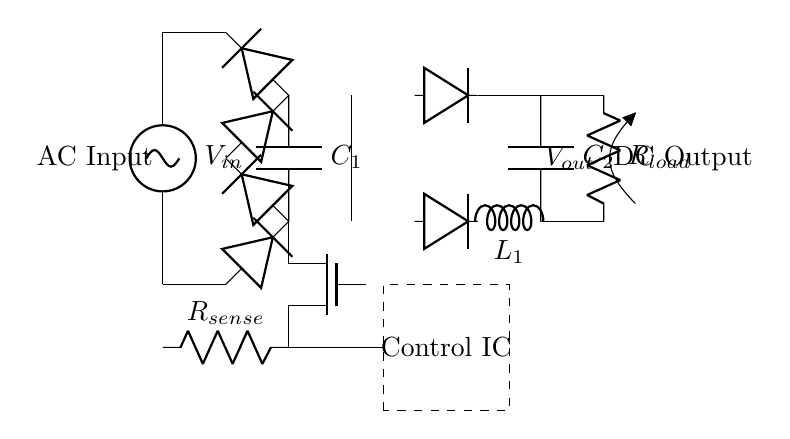What is the input voltage of the circuit? The input voltage is indicated as V_in, which is the source voltage supplying the circuit.
Answer: V_in What component smooths the rectified output? The smoothing capacitor labeled C_1 is connected between the two outputs of the bridge rectifier to filter the DC output and reduce ripple.
Answer: C_1 How many diodes are present in the bridge rectifier? The bridge rectifier consists of four diodes that are configured to allow current to flow in the correct direction, converting AC to DC.
Answer: Four What is the purpose of the MOSFET switch? The MOSFET switch is used for high-frequency switching in the circuit, enabling control over the power delivered to the load by rapidly turning on and off.
Answer: High-frequency switching What is the type of output current in this circuit? The output after the smoothing capacitor is a direct current (DC) supplied to the load, which is typical for power supplies intended for desktop workstations.
Answer: DC What is the function of the control IC? The control integrated circuit manages the operation of the circuit by controlling the switching of the MOSFET based on feedback signals, regulating the output voltage.
Answer: Regulation Which component indicates the presence of inductance in the circuit? The inductor labeled L_1 is specifically meant to store energy in its magnetic field, indicating the presence of inductance in the output stage of the power supply.
Answer: L_1 